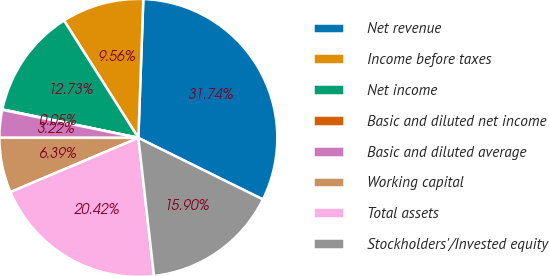<chart> <loc_0><loc_0><loc_500><loc_500><pie_chart><fcel>Net revenue<fcel>Income before taxes<fcel>Net income<fcel>Basic and diluted net income<fcel>Basic and diluted average<fcel>Working capital<fcel>Total assets<fcel>Stockholders'/Invested equity<nl><fcel>31.74%<fcel>9.56%<fcel>12.73%<fcel>0.05%<fcel>3.22%<fcel>6.39%<fcel>20.42%<fcel>15.9%<nl></chart> 